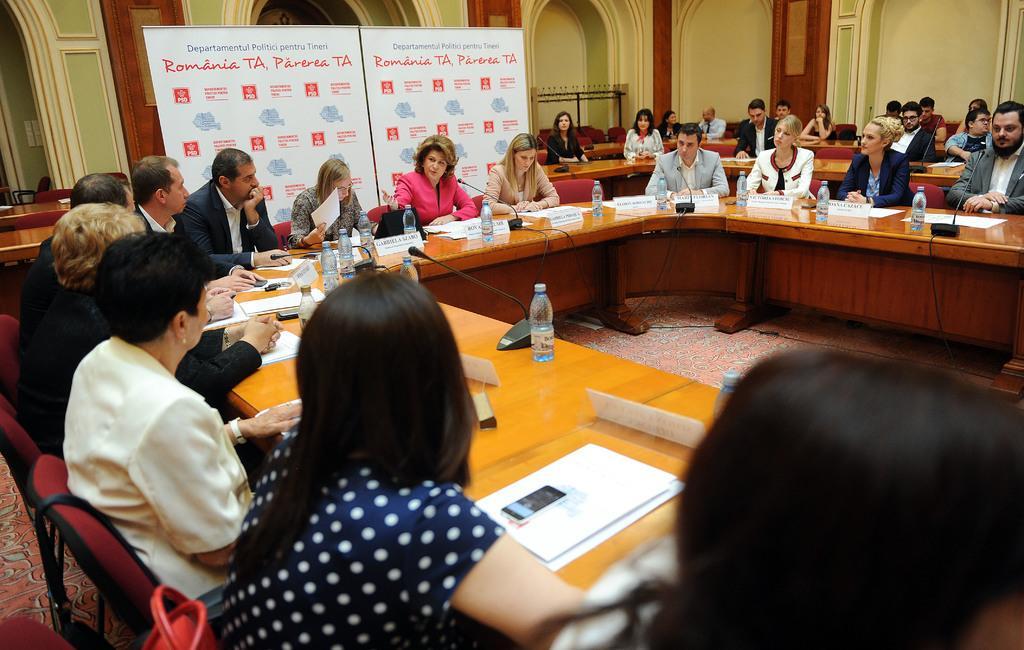Describe this image in one or two sentences. This picture shows a conference hall in which many people are sitting around a table in their chairs. On the table there are some papers, files, name plates, mobiles and water bottles here. Everybody is having a microphone in front of them. There are men and women in this group. In the background there is a poster on a wall here. 